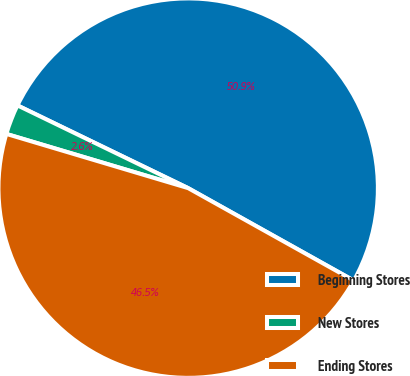<chart> <loc_0><loc_0><loc_500><loc_500><pie_chart><fcel>Beginning Stores<fcel>New Stores<fcel>Ending Stores<nl><fcel>50.92%<fcel>2.57%<fcel>46.51%<nl></chart> 